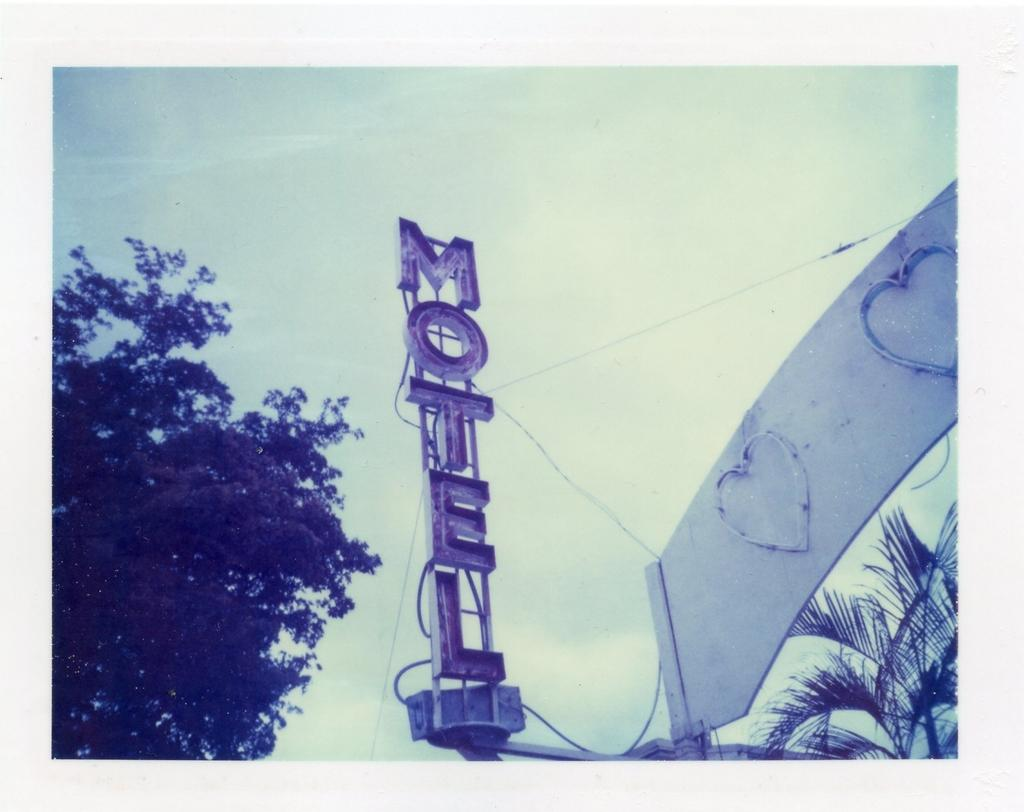What structure is located on the right side of the image? There is an arch on the right side of the image. What type of vegetation is on the right side of the image? There are trees on the right side of the image. What is the purpose of the name board in the image? The name board in the image is likely used for identification or direction. What type of vegetation is on the left side of the image? There is a tree on the left side of the image. What is visible in the background of the image? The sky is visible in the background of the image. What type of ice can be seen melting on the name board in the image? There is no ice present on the name board in the image. What shape is the pancake on the left side of the image? There is no pancake present in the image. 